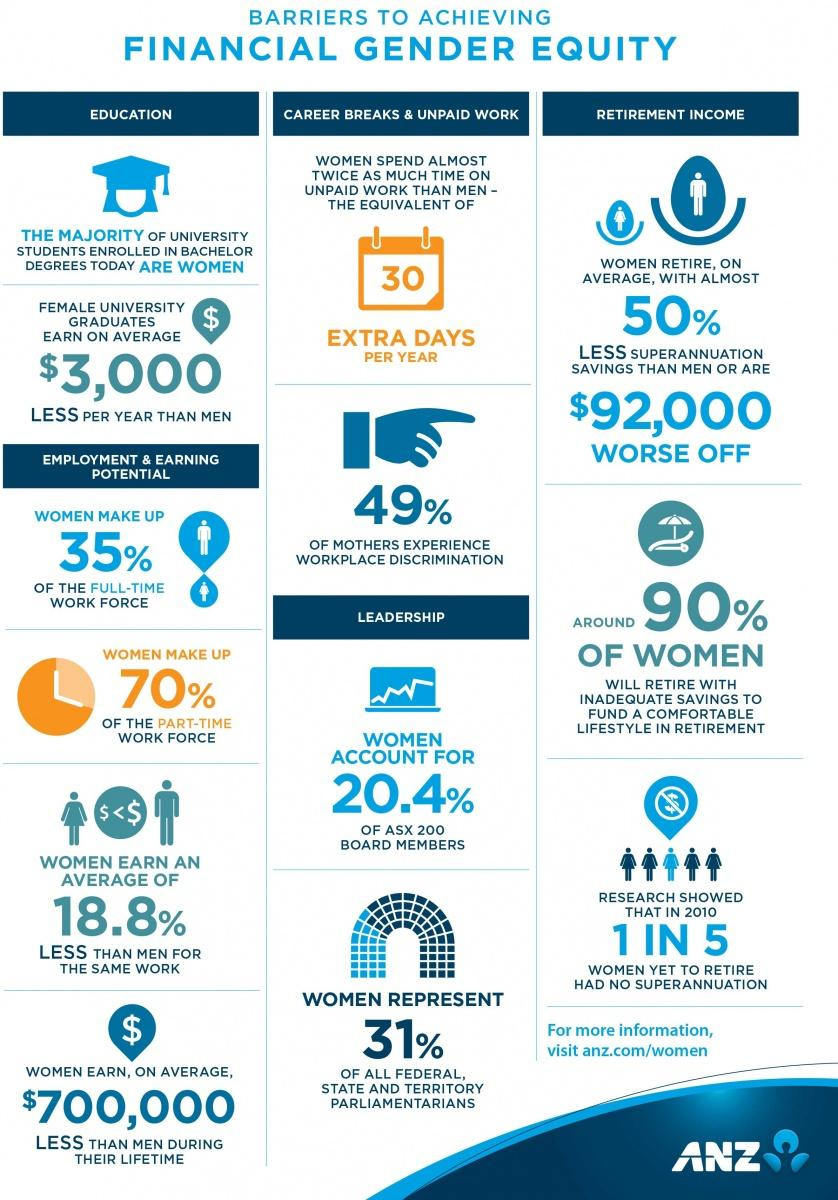Point out several critical features in this image. In 2010, approximately 20% of women who had not yet retired and were eligible to contribute to superannuation did not have any superannuation savings. The average difference in earnings between men and women for the same work is 18.8%. 